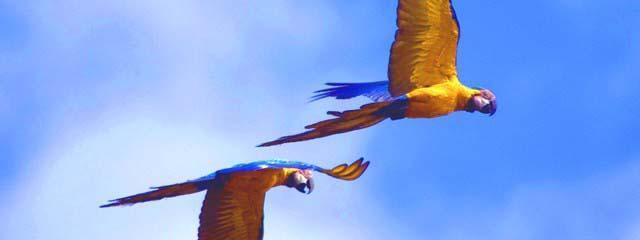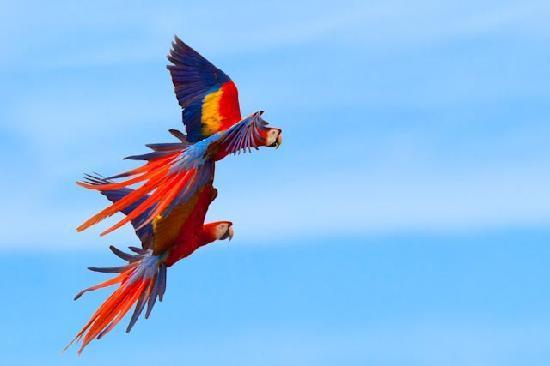The first image is the image on the left, the second image is the image on the right. Examine the images to the left and right. Is the description "There are 4 or more parrots flying to the right." accurate? Answer yes or no. Yes. 